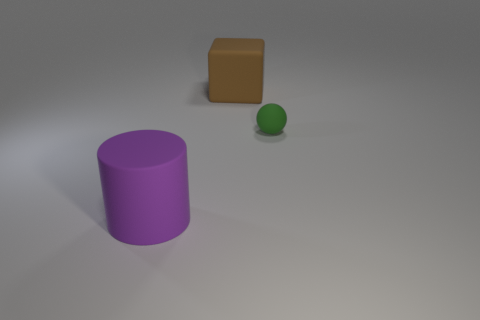There is a object on the right side of the large matte object to the right of the purple cylinder; what is its size?
Offer a terse response. Small. Is the size of the brown thing the same as the rubber ball?
Keep it short and to the point. No. There is a block that is made of the same material as the purple cylinder; what color is it?
Make the answer very short. Brown. Are the tiny green thing and the big object that is in front of the brown matte block made of the same material?
Your answer should be compact. Yes. What number of other large brown cubes have the same material as the large cube?
Your answer should be very brief. 0. There is a large thing in front of the brown thing; what is its shape?
Ensure brevity in your answer.  Cylinder. Do the large object behind the big purple thing and the object that is right of the brown matte cube have the same material?
Ensure brevity in your answer.  Yes. Are there any brown objects of the same shape as the big purple thing?
Your response must be concise. No. What number of objects are either big objects that are in front of the block or small red blocks?
Offer a terse response. 1. Is the number of matte things that are in front of the brown object greater than the number of large brown blocks right of the green matte object?
Offer a very short reply. Yes. 